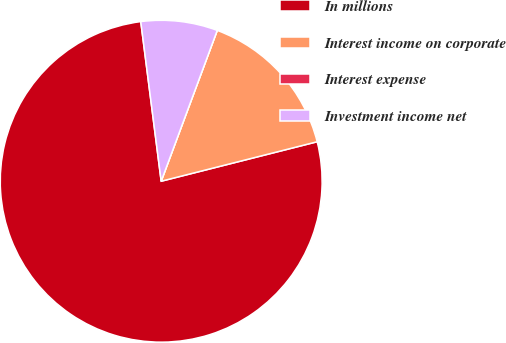Convert chart to OTSL. <chart><loc_0><loc_0><loc_500><loc_500><pie_chart><fcel>In millions<fcel>Interest income on corporate<fcel>Interest expense<fcel>Investment income net<nl><fcel>76.92%<fcel>15.39%<fcel>0.0%<fcel>7.69%<nl></chart> 